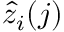Convert formula to latex. <formula><loc_0><loc_0><loc_500><loc_500>\hat { z } _ { i } ( j )</formula> 